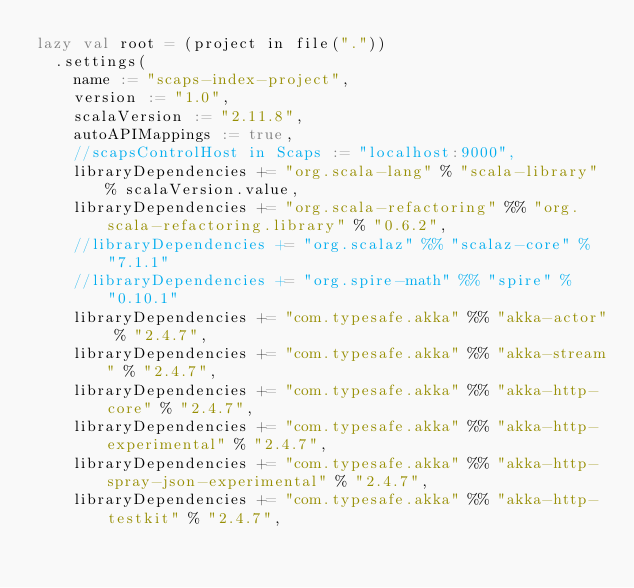Convert code to text. <code><loc_0><loc_0><loc_500><loc_500><_Scala_>lazy val root = (project in file("."))
  .settings(
    name := "scaps-index-project",
    version := "1.0",
    scalaVersion := "2.11.8",
    autoAPIMappings := true,
    //scapsControlHost in Scaps := "localhost:9000",
    libraryDependencies += "org.scala-lang" % "scala-library" % scalaVersion.value,
    libraryDependencies += "org.scala-refactoring" %% "org.scala-refactoring.library" % "0.6.2",
    //libraryDependencies += "org.scalaz" %% "scalaz-core" % "7.1.1"
    //libraryDependencies += "org.spire-math" %% "spire" % "0.10.1"
    libraryDependencies += "com.typesafe.akka" %% "akka-actor" % "2.4.7",
    libraryDependencies += "com.typesafe.akka" %% "akka-stream" % "2.4.7",
    libraryDependencies += "com.typesafe.akka" %% "akka-http-core" % "2.4.7",
    libraryDependencies += "com.typesafe.akka" %% "akka-http-experimental" % "2.4.7",
    libraryDependencies += "com.typesafe.akka" %% "akka-http-spray-json-experimental" % "2.4.7",
    libraryDependencies += "com.typesafe.akka" %% "akka-http-testkit" % "2.4.7",</code> 